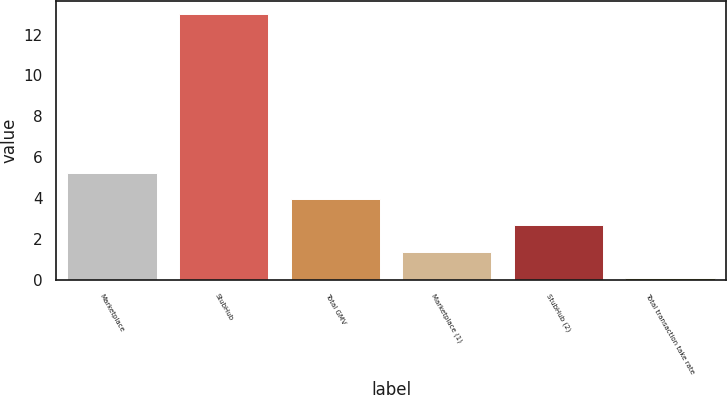Convert chart. <chart><loc_0><loc_0><loc_500><loc_500><bar_chart><fcel>Marketplace<fcel>StubHub<fcel>Total GMV<fcel>Marketplace (1)<fcel>StubHub (2)<fcel>Total transaction take rate<nl><fcel>5.23<fcel>13<fcel>3.94<fcel>1.36<fcel>2.65<fcel>0.07<nl></chart> 